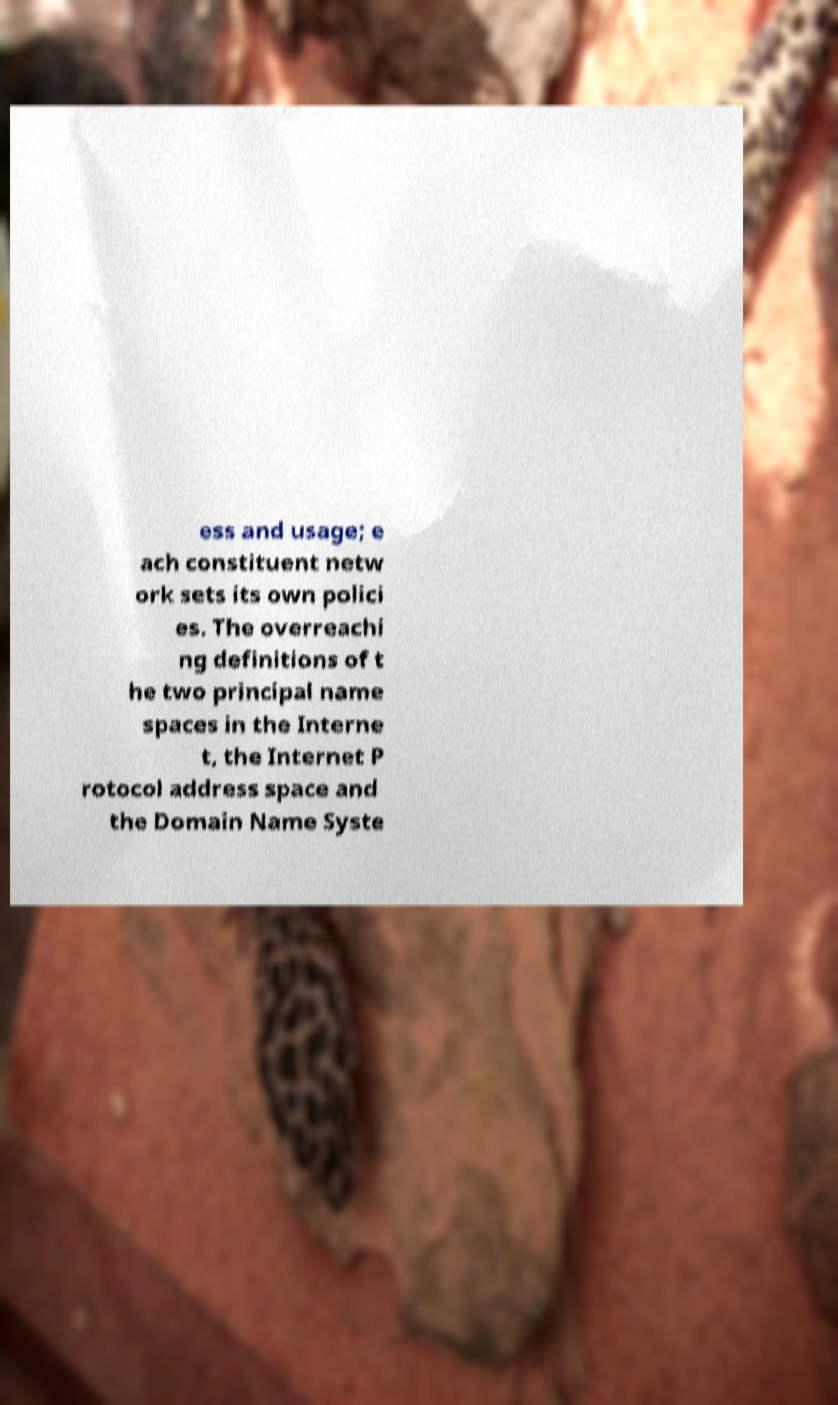Could you assist in decoding the text presented in this image and type it out clearly? ess and usage; e ach constituent netw ork sets its own polici es. The overreachi ng definitions of t he two principal name spaces in the Interne t, the Internet P rotocol address space and the Domain Name Syste 